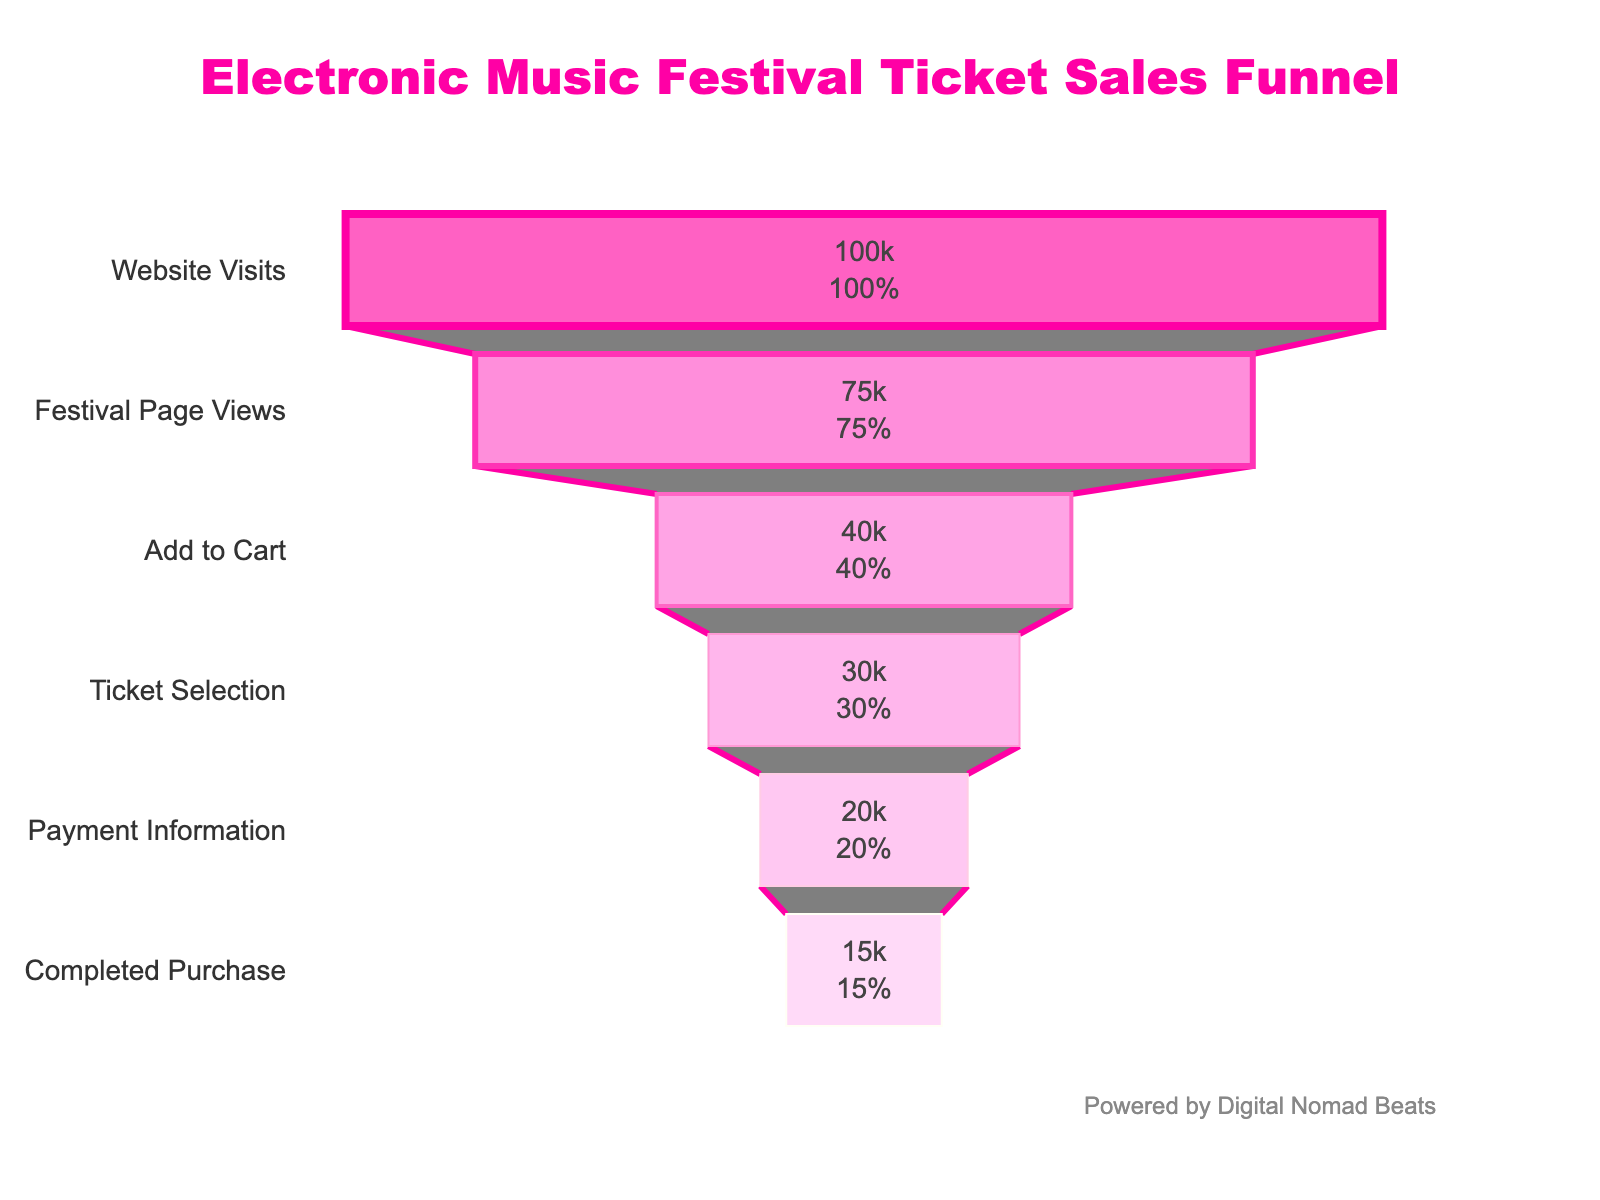What is the title of the funnel chart? The title is usually displayed at the top of the chart. By referring to the figure, we can see the title text.
Answer: Electronic Music Festival Ticket Sales Funnel How many stages are there in the funnel? The stages are represented by horizontal bars in the funnel. By counting each bar, we determine the number of stages.
Answer: 6 What percentage of website visits result in a completed purchase? To find this, look at the percent initial value at the "Completed Purchase" stage, which shows the percentage relative to the initial website visits.
Answer: 15% Which stage has the biggest drop-off in visitors? By comparing the count of visitors between stages, the largest numerical drop from one stage to the next represents the biggest drop-off. From "Website Visits" to "Festival Page Views" (100,000 to 75,000) is the largest drop.
Answer: Festival Page Views What is the difference in visitors between the Ticket Selection and Payment Information stages? Subtract the visitors of the Payment Information stage (20,000) from the visitors of the Ticket Selection stage (30,000).
Answer: 10,000 How many visitors added tickets to their cart but did not complete the purchase? The visitors who added to cart but did not proceed to completed purchase can be found by subtracting the completed purchase visitors (15,000) from the visitors at add to cart stage (40,000).
Answer: 25,000 Which stage marks the transition from 30,000 to 20,000 visitors? By looking at the counts of visitors at each stage, identify the stage transitioning from 30,000 to 20,000 visitors.
Answer: Payment Information Calculate the overall conversion rate from the Festival Page Views to Completed Purchase. Divide the number of completed purchases (15,000) by the number of festival page views (75,000), then multiply by 100 to convert it to a percentage.
Answer: 20% What are the colors used to represent the stages in the funnel? Each bar in the funnel chart is filled with different colors. The visual information shows the sequence of these colors.
Answer: Shades of pink What stage immediately follows 'Add to Cart' in the funnel? By reading the stages in sequence from top to bottom, identify the stage that follows 'Add to Cart'.
Answer: Ticket Selection 